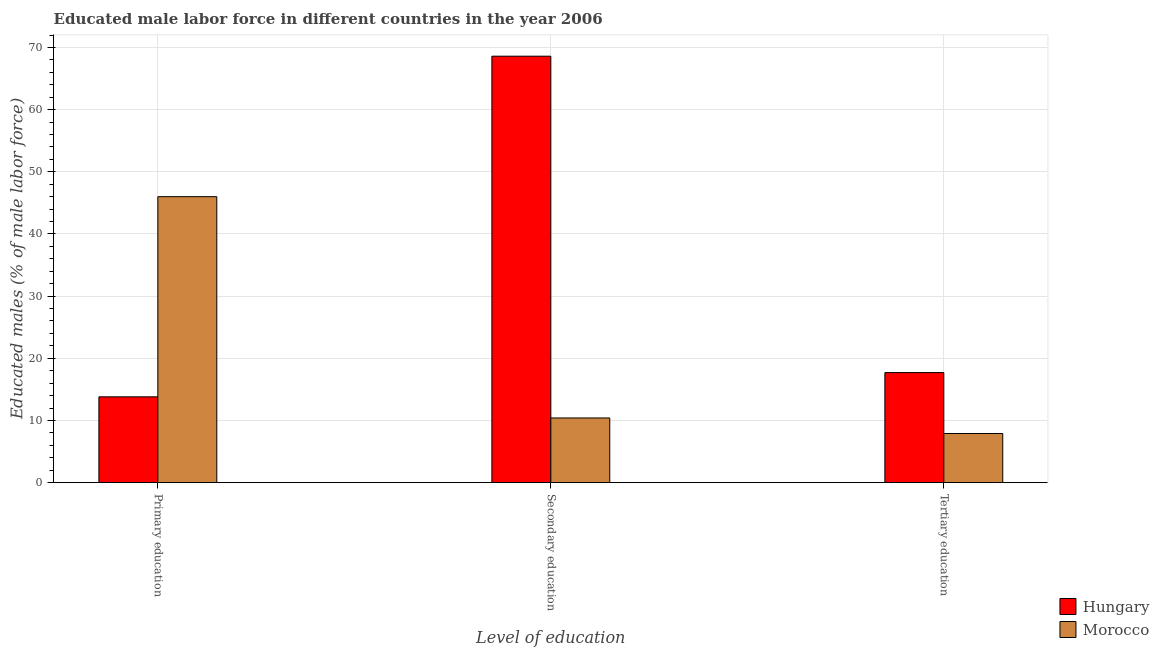How many different coloured bars are there?
Your answer should be very brief. 2. How many groups of bars are there?
Offer a very short reply. 3. Are the number of bars per tick equal to the number of legend labels?
Give a very brief answer. Yes. What is the label of the 2nd group of bars from the left?
Offer a very short reply. Secondary education. What is the percentage of male labor force who received secondary education in Hungary?
Your answer should be very brief. 68.6. Across all countries, what is the minimum percentage of male labor force who received tertiary education?
Make the answer very short. 7.9. In which country was the percentage of male labor force who received secondary education maximum?
Give a very brief answer. Hungary. In which country was the percentage of male labor force who received tertiary education minimum?
Give a very brief answer. Morocco. What is the total percentage of male labor force who received tertiary education in the graph?
Give a very brief answer. 25.6. What is the difference between the percentage of male labor force who received tertiary education in Hungary and that in Morocco?
Your response must be concise. 9.8. What is the difference between the percentage of male labor force who received primary education in Hungary and the percentage of male labor force who received secondary education in Morocco?
Make the answer very short. 3.4. What is the average percentage of male labor force who received primary education per country?
Offer a very short reply. 29.9. What is the difference between the percentage of male labor force who received secondary education and percentage of male labor force who received primary education in Morocco?
Offer a terse response. -35.6. What is the ratio of the percentage of male labor force who received primary education in Morocco to that in Hungary?
Ensure brevity in your answer.  3.33. What is the difference between the highest and the second highest percentage of male labor force who received secondary education?
Offer a terse response. 58.2. What is the difference between the highest and the lowest percentage of male labor force who received primary education?
Your answer should be very brief. 32.2. Is the sum of the percentage of male labor force who received secondary education in Morocco and Hungary greater than the maximum percentage of male labor force who received primary education across all countries?
Keep it short and to the point. Yes. What does the 1st bar from the left in Tertiary education represents?
Your answer should be compact. Hungary. What does the 2nd bar from the right in Secondary education represents?
Keep it short and to the point. Hungary. Are all the bars in the graph horizontal?
Offer a terse response. No. How many countries are there in the graph?
Your answer should be very brief. 2. What is the difference between two consecutive major ticks on the Y-axis?
Keep it short and to the point. 10. Are the values on the major ticks of Y-axis written in scientific E-notation?
Provide a short and direct response. No. Where does the legend appear in the graph?
Offer a terse response. Bottom right. How are the legend labels stacked?
Give a very brief answer. Vertical. What is the title of the graph?
Ensure brevity in your answer.  Educated male labor force in different countries in the year 2006. Does "Namibia" appear as one of the legend labels in the graph?
Offer a terse response. No. What is the label or title of the X-axis?
Offer a terse response. Level of education. What is the label or title of the Y-axis?
Your answer should be very brief. Educated males (% of male labor force). What is the Educated males (% of male labor force) in Hungary in Primary education?
Keep it short and to the point. 13.8. What is the Educated males (% of male labor force) in Morocco in Primary education?
Ensure brevity in your answer.  46. What is the Educated males (% of male labor force) in Hungary in Secondary education?
Offer a very short reply. 68.6. What is the Educated males (% of male labor force) in Morocco in Secondary education?
Your answer should be very brief. 10.4. What is the Educated males (% of male labor force) in Hungary in Tertiary education?
Provide a succinct answer. 17.7. What is the Educated males (% of male labor force) in Morocco in Tertiary education?
Your answer should be very brief. 7.9. Across all Level of education, what is the maximum Educated males (% of male labor force) of Hungary?
Provide a short and direct response. 68.6. Across all Level of education, what is the maximum Educated males (% of male labor force) of Morocco?
Offer a very short reply. 46. Across all Level of education, what is the minimum Educated males (% of male labor force) in Hungary?
Your response must be concise. 13.8. Across all Level of education, what is the minimum Educated males (% of male labor force) in Morocco?
Your answer should be very brief. 7.9. What is the total Educated males (% of male labor force) of Hungary in the graph?
Your response must be concise. 100.1. What is the total Educated males (% of male labor force) in Morocco in the graph?
Provide a short and direct response. 64.3. What is the difference between the Educated males (% of male labor force) in Hungary in Primary education and that in Secondary education?
Your answer should be very brief. -54.8. What is the difference between the Educated males (% of male labor force) in Morocco in Primary education and that in Secondary education?
Keep it short and to the point. 35.6. What is the difference between the Educated males (% of male labor force) of Morocco in Primary education and that in Tertiary education?
Offer a very short reply. 38.1. What is the difference between the Educated males (% of male labor force) in Hungary in Secondary education and that in Tertiary education?
Ensure brevity in your answer.  50.9. What is the difference between the Educated males (% of male labor force) of Morocco in Secondary education and that in Tertiary education?
Make the answer very short. 2.5. What is the difference between the Educated males (% of male labor force) of Hungary in Secondary education and the Educated males (% of male labor force) of Morocco in Tertiary education?
Your answer should be very brief. 60.7. What is the average Educated males (% of male labor force) in Hungary per Level of education?
Your answer should be compact. 33.37. What is the average Educated males (% of male labor force) in Morocco per Level of education?
Offer a very short reply. 21.43. What is the difference between the Educated males (% of male labor force) in Hungary and Educated males (% of male labor force) in Morocco in Primary education?
Offer a very short reply. -32.2. What is the difference between the Educated males (% of male labor force) of Hungary and Educated males (% of male labor force) of Morocco in Secondary education?
Provide a short and direct response. 58.2. What is the difference between the Educated males (% of male labor force) of Hungary and Educated males (% of male labor force) of Morocco in Tertiary education?
Make the answer very short. 9.8. What is the ratio of the Educated males (% of male labor force) of Hungary in Primary education to that in Secondary education?
Your answer should be very brief. 0.2. What is the ratio of the Educated males (% of male labor force) of Morocco in Primary education to that in Secondary education?
Your answer should be very brief. 4.42. What is the ratio of the Educated males (% of male labor force) of Hungary in Primary education to that in Tertiary education?
Your response must be concise. 0.78. What is the ratio of the Educated males (% of male labor force) of Morocco in Primary education to that in Tertiary education?
Your answer should be very brief. 5.82. What is the ratio of the Educated males (% of male labor force) in Hungary in Secondary education to that in Tertiary education?
Provide a short and direct response. 3.88. What is the ratio of the Educated males (% of male labor force) in Morocco in Secondary education to that in Tertiary education?
Provide a short and direct response. 1.32. What is the difference between the highest and the second highest Educated males (% of male labor force) in Hungary?
Provide a succinct answer. 50.9. What is the difference between the highest and the second highest Educated males (% of male labor force) in Morocco?
Give a very brief answer. 35.6. What is the difference between the highest and the lowest Educated males (% of male labor force) of Hungary?
Your answer should be very brief. 54.8. What is the difference between the highest and the lowest Educated males (% of male labor force) in Morocco?
Offer a terse response. 38.1. 